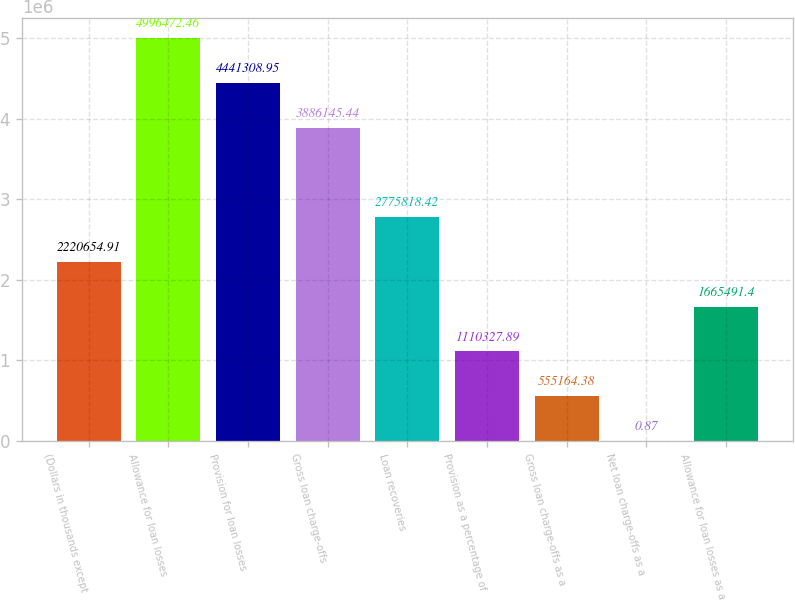<chart> <loc_0><loc_0><loc_500><loc_500><bar_chart><fcel>(Dollars in thousands except<fcel>Allowance for loan losses<fcel>Provision for loan losses<fcel>Gross loan charge-offs<fcel>Loan recoveries<fcel>Provision as a percentage of<fcel>Gross loan charge-offs as a<fcel>Net loan charge-offs as a<fcel>Allowance for loan losses as a<nl><fcel>2.22065e+06<fcel>4.99647e+06<fcel>4.44131e+06<fcel>3.88615e+06<fcel>2.77582e+06<fcel>1.11033e+06<fcel>555164<fcel>0.87<fcel>1.66549e+06<nl></chart> 